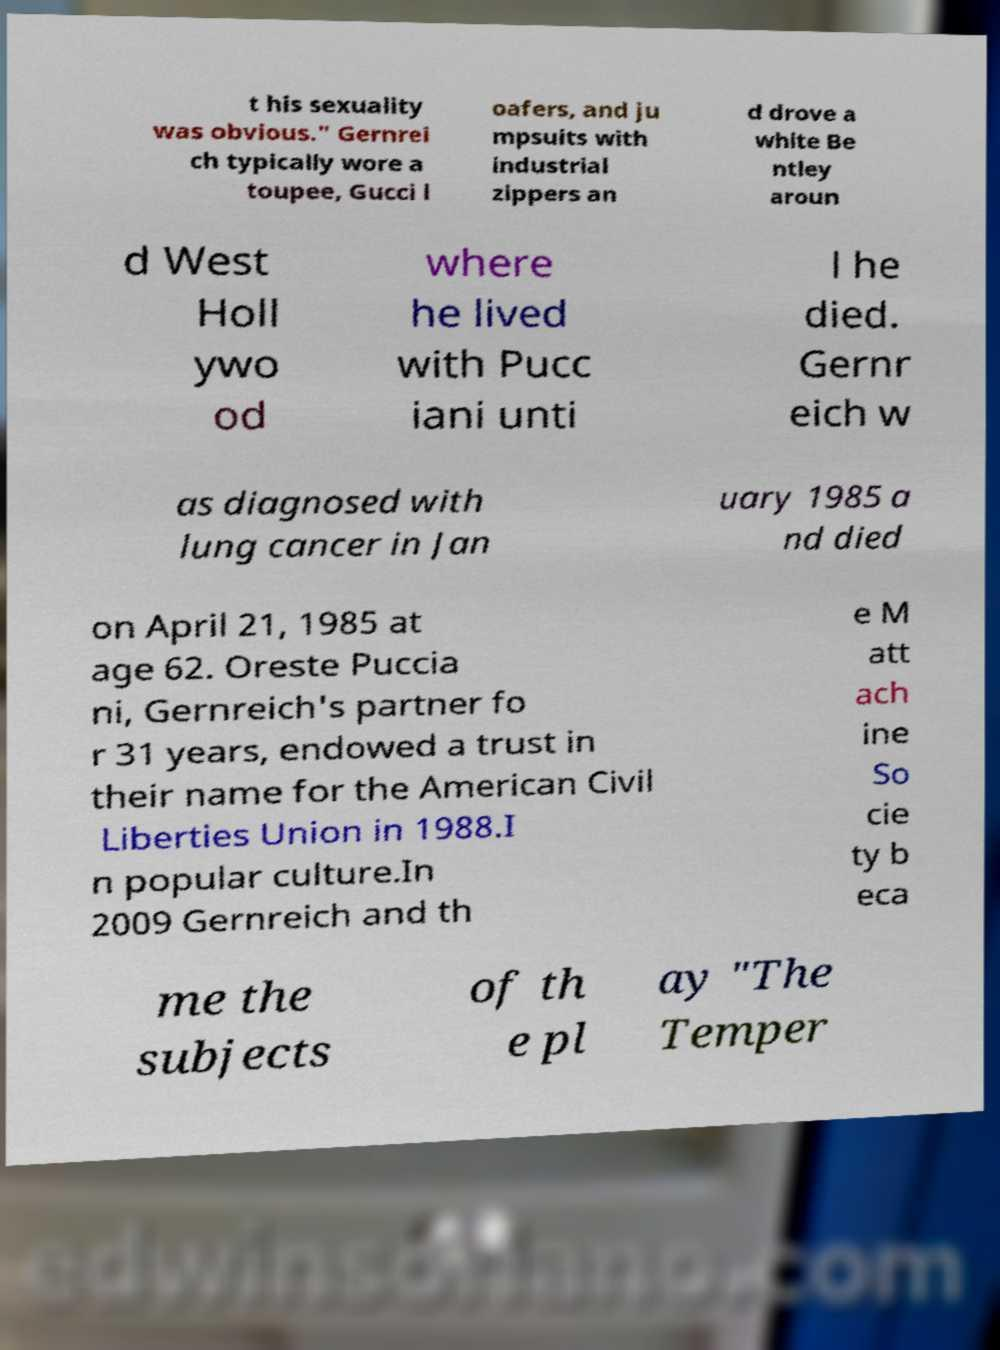Please identify and transcribe the text found in this image. t his sexuality was obvious." Gernrei ch typically wore a toupee, Gucci l oafers, and ju mpsuits with industrial zippers an d drove a white Be ntley aroun d West Holl ywo od where he lived with Pucc iani unti l he died. Gernr eich w as diagnosed with lung cancer in Jan uary 1985 a nd died on April 21, 1985 at age 62. Oreste Puccia ni, Gernreich's partner fo r 31 years, endowed a trust in their name for the American Civil Liberties Union in 1988.I n popular culture.In 2009 Gernreich and th e M att ach ine So cie ty b eca me the subjects of th e pl ay "The Temper 